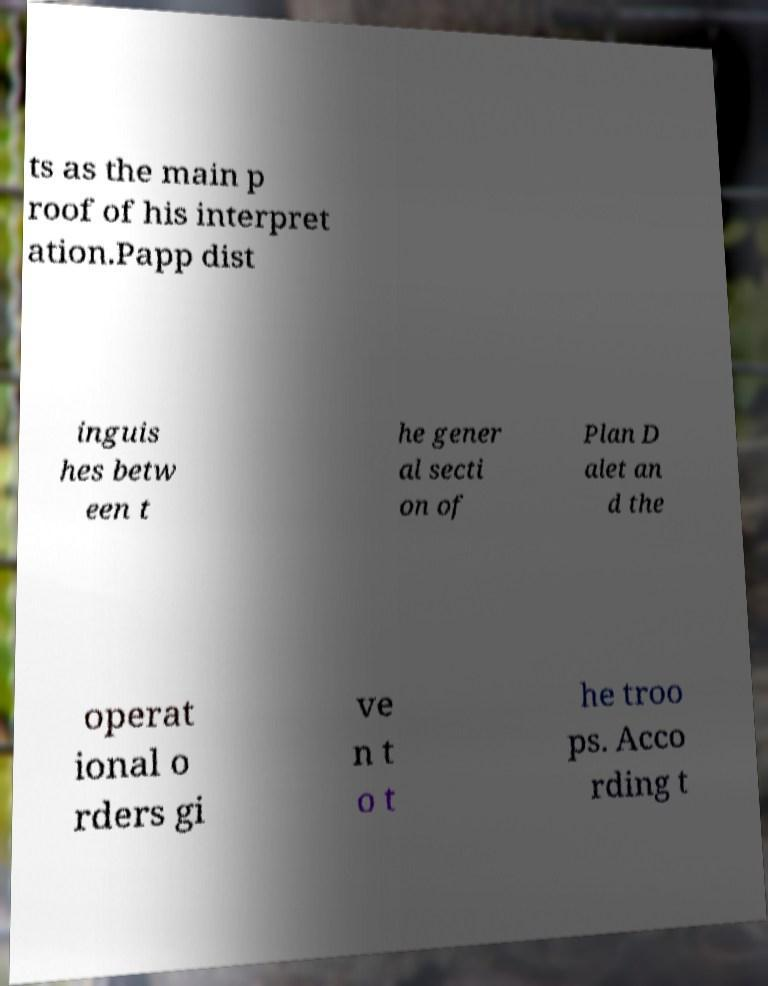For documentation purposes, I need the text within this image transcribed. Could you provide that? ts as the main p roof of his interpret ation.Papp dist inguis hes betw een t he gener al secti on of Plan D alet an d the operat ional o rders gi ve n t o t he troo ps. Acco rding t 